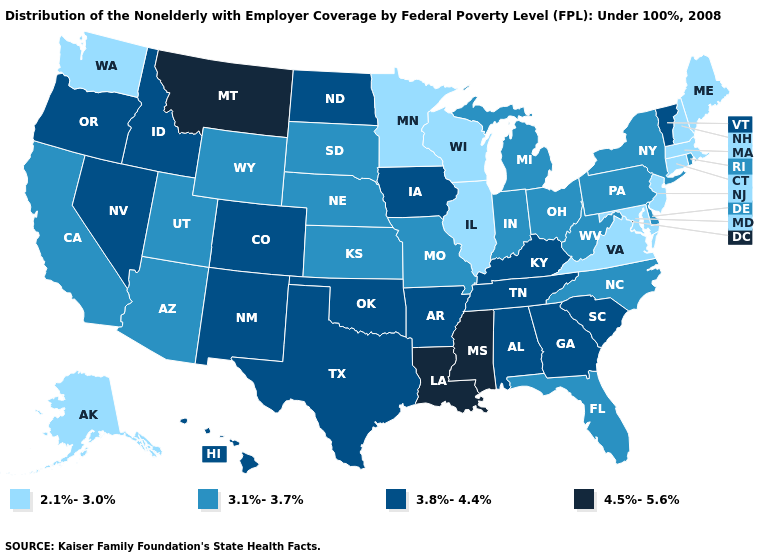Name the states that have a value in the range 3.1%-3.7%?
Give a very brief answer. Arizona, California, Delaware, Florida, Indiana, Kansas, Michigan, Missouri, Nebraska, New York, North Carolina, Ohio, Pennsylvania, Rhode Island, South Dakota, Utah, West Virginia, Wyoming. What is the lowest value in states that border Illinois?
Short answer required. 2.1%-3.0%. Name the states that have a value in the range 3.1%-3.7%?
Write a very short answer. Arizona, California, Delaware, Florida, Indiana, Kansas, Michigan, Missouri, Nebraska, New York, North Carolina, Ohio, Pennsylvania, Rhode Island, South Dakota, Utah, West Virginia, Wyoming. Name the states that have a value in the range 2.1%-3.0%?
Give a very brief answer. Alaska, Connecticut, Illinois, Maine, Maryland, Massachusetts, Minnesota, New Hampshire, New Jersey, Virginia, Washington, Wisconsin. How many symbols are there in the legend?
Write a very short answer. 4. Does New Jersey have the lowest value in the USA?
Concise answer only. Yes. Name the states that have a value in the range 4.5%-5.6%?
Quick response, please. Louisiana, Mississippi, Montana. Name the states that have a value in the range 2.1%-3.0%?
Answer briefly. Alaska, Connecticut, Illinois, Maine, Maryland, Massachusetts, Minnesota, New Hampshire, New Jersey, Virginia, Washington, Wisconsin. Among the states that border New Hampshire , which have the lowest value?
Be succinct. Maine, Massachusetts. Name the states that have a value in the range 2.1%-3.0%?
Give a very brief answer. Alaska, Connecticut, Illinois, Maine, Maryland, Massachusetts, Minnesota, New Hampshire, New Jersey, Virginia, Washington, Wisconsin. Does Connecticut have the same value as Utah?
Give a very brief answer. No. Which states have the highest value in the USA?
Short answer required. Louisiana, Mississippi, Montana. What is the value of South Dakota?
Keep it brief. 3.1%-3.7%. Name the states that have a value in the range 4.5%-5.6%?
Short answer required. Louisiana, Mississippi, Montana. What is the value of Indiana?
Quick response, please. 3.1%-3.7%. 